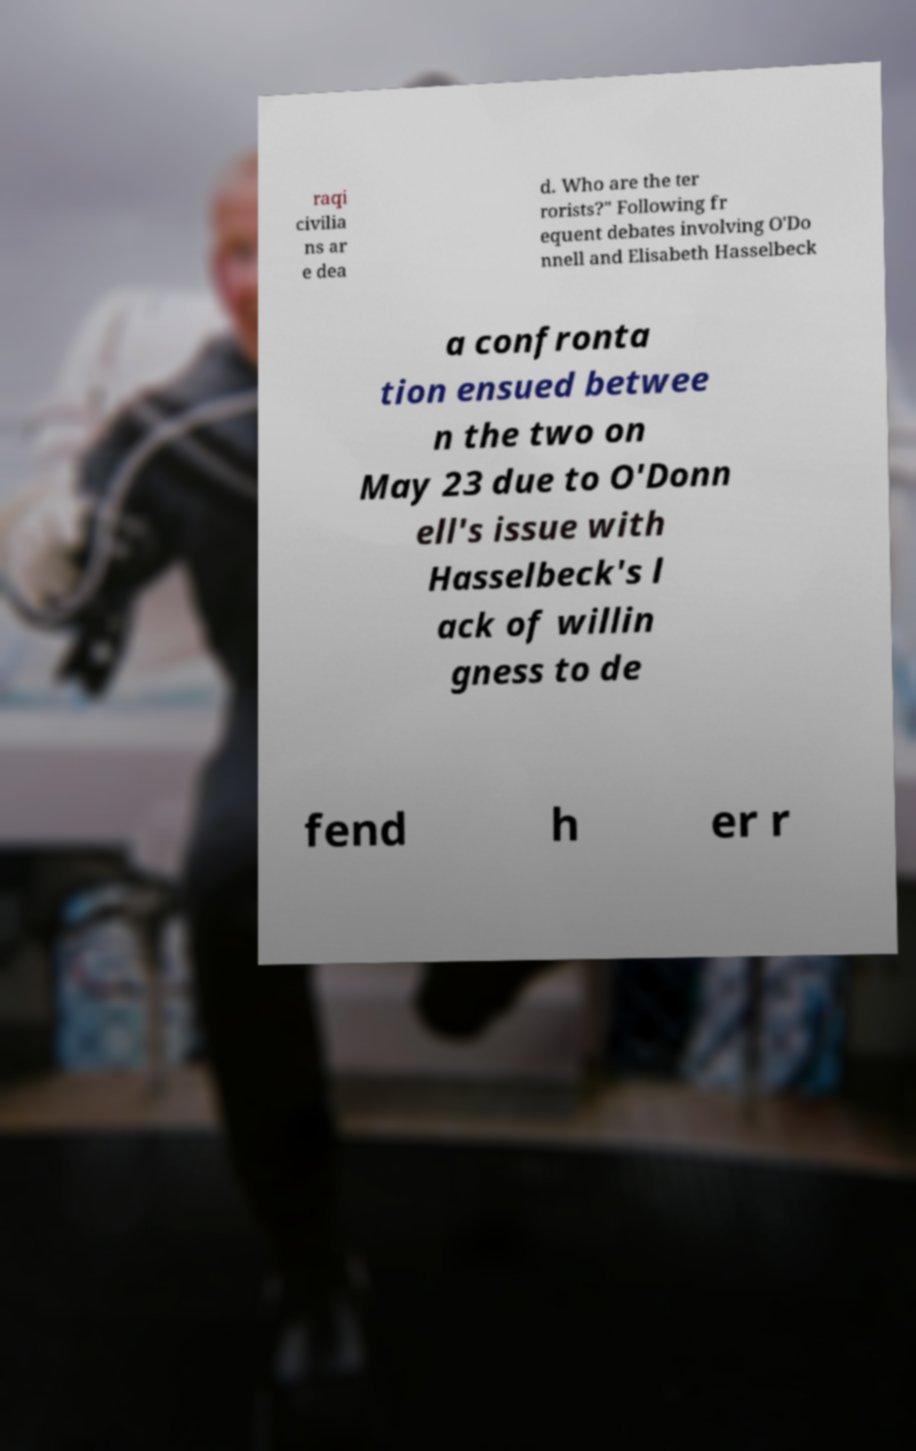Could you extract and type out the text from this image? raqi civilia ns ar e dea d. Who are the ter rorists?" Following fr equent debates involving O'Do nnell and Elisabeth Hasselbeck a confronta tion ensued betwee n the two on May 23 due to O'Donn ell's issue with Hasselbeck's l ack of willin gness to de fend h er r 